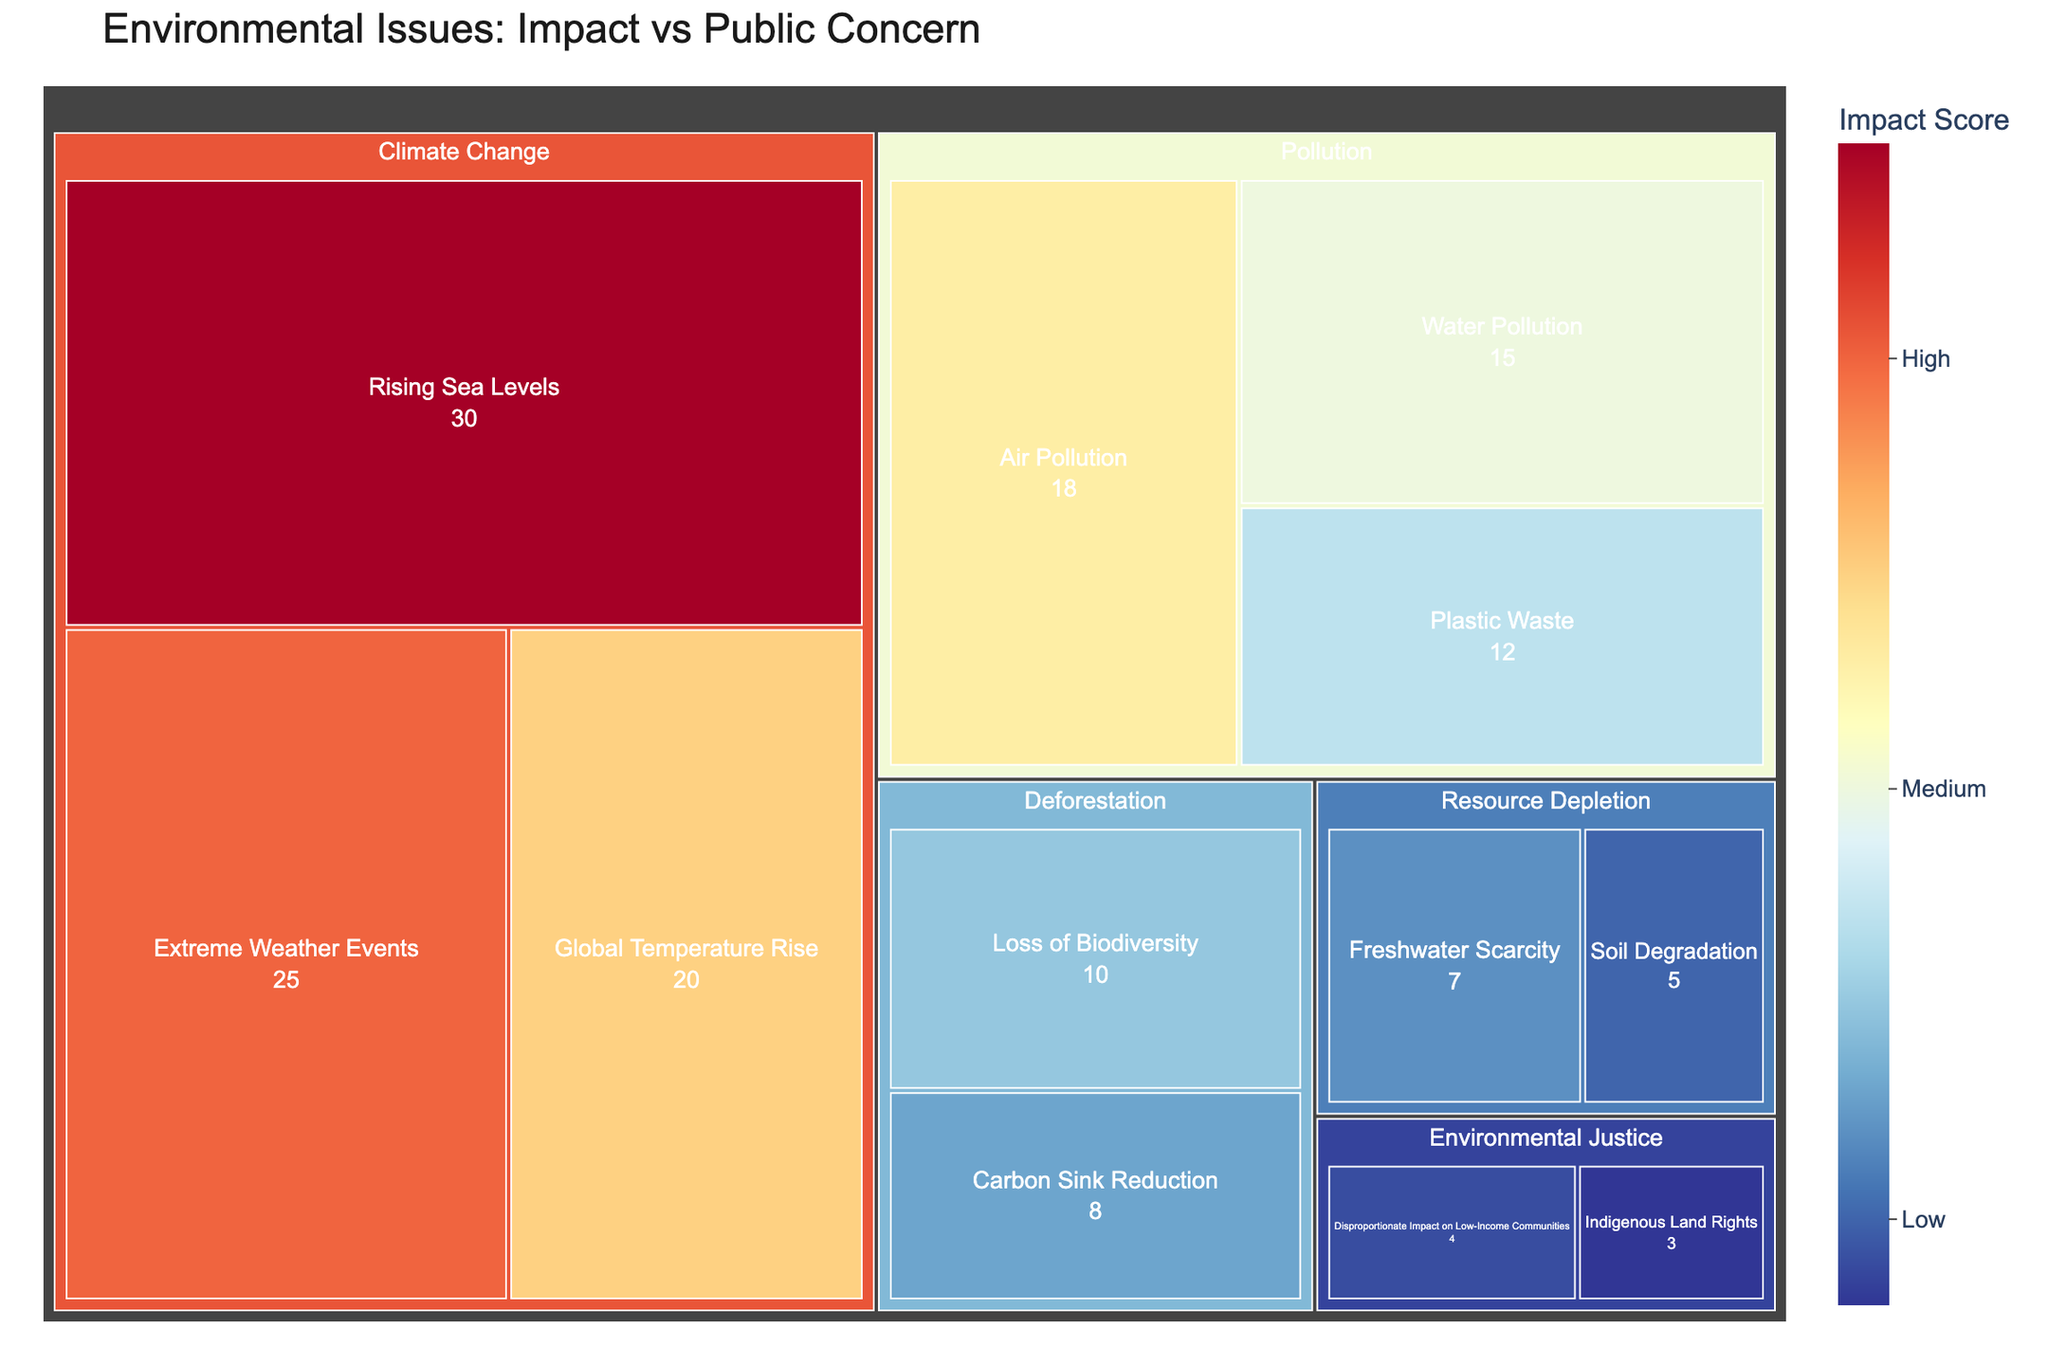What's the highest impact score and which subcategory does it belong to? The highest impact score can be seen in the box with the largest size and the highest color intensity. The "Rising Sea Levels" subcategory under "Climate Change" has the highest impact score of 30.
Answer: Rising Sea Levels with 30 Which category has the most subcategories? The category with the most subcategories will have the most inner boxes displaying under it. "Climate Change" has three subcategories: Rising Sea Levels, Extreme Weather Events, and Global Temperature Rise.
Answer: Climate Change What is the combined impact of pollution issues? To find the combined impact of pollution issues, sum the impact values of all subcategories under "Pollution": Air Pollution (18), Water Pollution (15), and Plastic Waste (12). The combined impact is 18 + 15 + 12 = 45.
Answer: 45 Which subcategory has the lowest impact score and in which category is it? The subcategory with the smallest size and lowest color intensity will have the lowest impact score. "Indigenous Land Rights" under "Environmental Justice" has the lowest impact score of 3.
Answer: Indigenous Land Rights with 3 Is the impact score of air pollution greater than that of freshwater scarcity? To compare impact scores, check the values associated with both subcategories. The impact score of Air Pollution is 18, and Freshwater Scarcity is 7. 18 is greater than 7.
Answer: Yes What is the average impact score of subcategories under deforestation? Average calculation involves summing the impact values of the subcategories under "Deforestation" and dividing by the number of subcategories. The sum is 10 (Loss of Biodiversity) + 8 (Carbon Sink Reduction) = 18. There are 2 subcategories, so the average is 18 / 2 = 9.
Answer: 9 Which category has the highest combined impact score? Calculate the combined impact score by summing the impact values of all subcategories under each main category. "Climate Change" has a combined score of 30 (Rising Sea Levels) + 25 (Extreme Weather Events) + 20 (Global Temperature Rise) = 75, which is the highest.
Answer: Climate Change What is the difference in impact scores between the highest and lowest subcategories? To find the difference, subtract the lowest impact score from the highest. The highest is "Rising Sea Levels" with 30 and the lowest is "Indigenous Land Rights" with 3. The difference is 30 - 3 = 27.
Answer: 27 